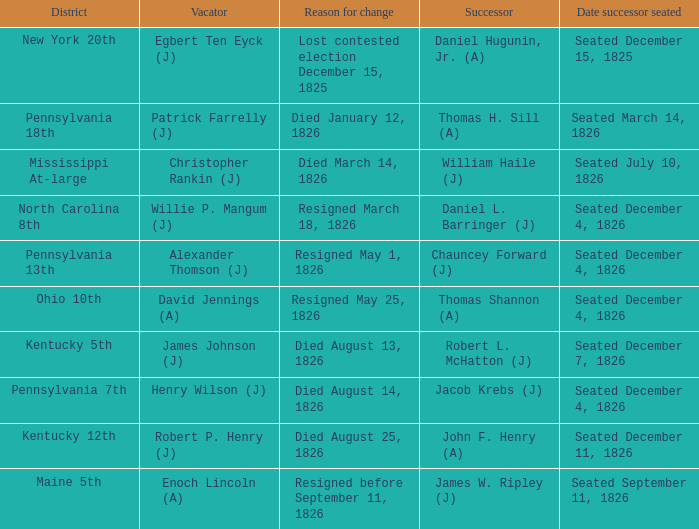Identify the cause for alteration in pennsylvania's 13th. Resigned May 1, 1826. Help me parse the entirety of this table. {'header': ['District', 'Vacator', 'Reason for change', 'Successor', 'Date successor seated'], 'rows': [['New York 20th', 'Egbert Ten Eyck (J)', 'Lost contested election December 15, 1825', 'Daniel Hugunin, Jr. (A)', 'Seated December 15, 1825'], ['Pennsylvania 18th', 'Patrick Farrelly (J)', 'Died January 12, 1826', 'Thomas H. Sill (A)', 'Seated March 14, 1826'], ['Mississippi At-large', 'Christopher Rankin (J)', 'Died March 14, 1826', 'William Haile (J)', 'Seated July 10, 1826'], ['North Carolina 8th', 'Willie P. Mangum (J)', 'Resigned March 18, 1826', 'Daniel L. Barringer (J)', 'Seated December 4, 1826'], ['Pennsylvania 13th', 'Alexander Thomson (J)', 'Resigned May 1, 1826', 'Chauncey Forward (J)', 'Seated December 4, 1826'], ['Ohio 10th', 'David Jennings (A)', 'Resigned May 25, 1826', 'Thomas Shannon (A)', 'Seated December 4, 1826'], ['Kentucky 5th', 'James Johnson (J)', 'Died August 13, 1826', 'Robert L. McHatton (J)', 'Seated December 7, 1826'], ['Pennsylvania 7th', 'Henry Wilson (J)', 'Died August 14, 1826', 'Jacob Krebs (J)', 'Seated December 4, 1826'], ['Kentucky 12th', 'Robert P. Henry (J)', 'Died August 25, 1826', 'John F. Henry (A)', 'Seated December 11, 1826'], ['Maine 5th', 'Enoch Lincoln (A)', 'Resigned before September 11, 1826', 'James W. Ripley (J)', 'Seated September 11, 1826']]} 